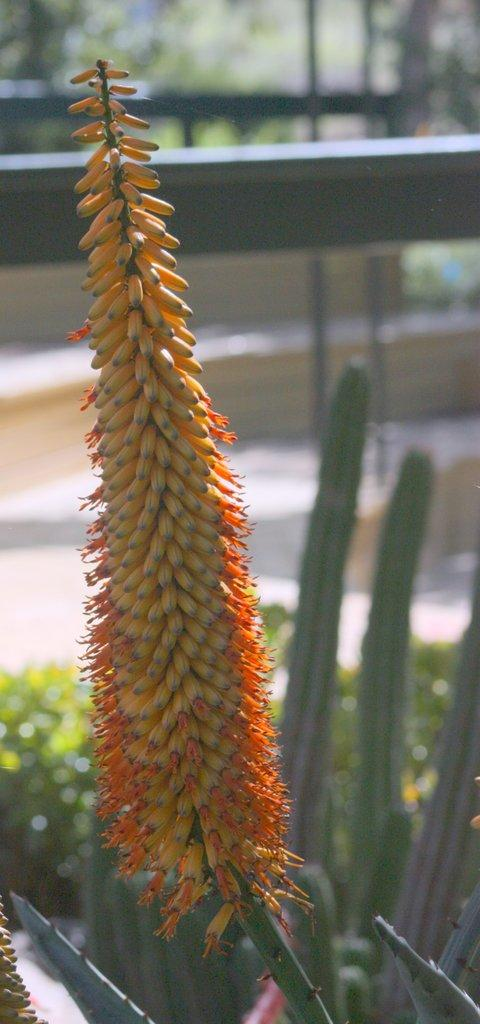What is present on the stem in the image? There are buds on a stem in the image. What type of living organisms can be seen in the image? Plants are present in the image. Can you describe the background of the image? The background of the image is blurred. What type of thread is being used to conduct a science experiment in the image? There is no thread or science experiment present in the image. What advice might the mom give about the plants in the image? There is no mom present in the image, so it is not possible to determine what advice she might give. 